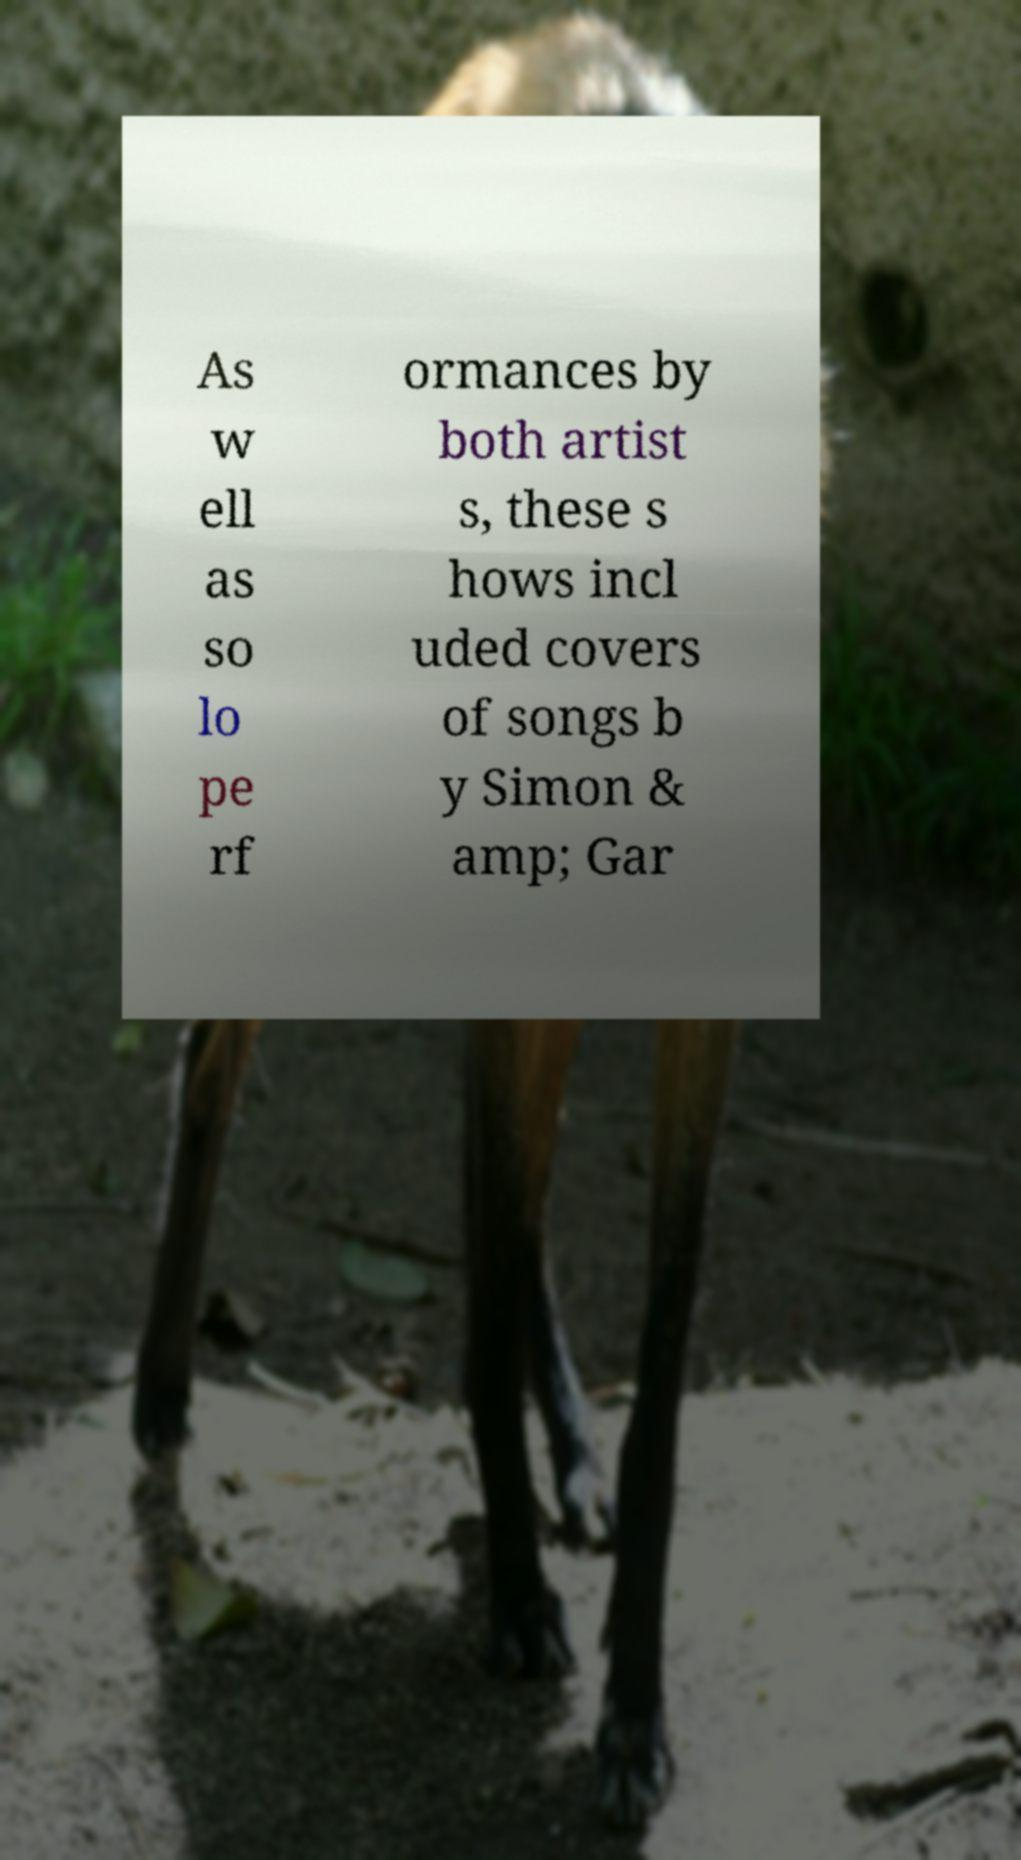For documentation purposes, I need the text within this image transcribed. Could you provide that? As w ell as so lo pe rf ormances by both artist s, these s hows incl uded covers of songs b y Simon & amp; Gar 